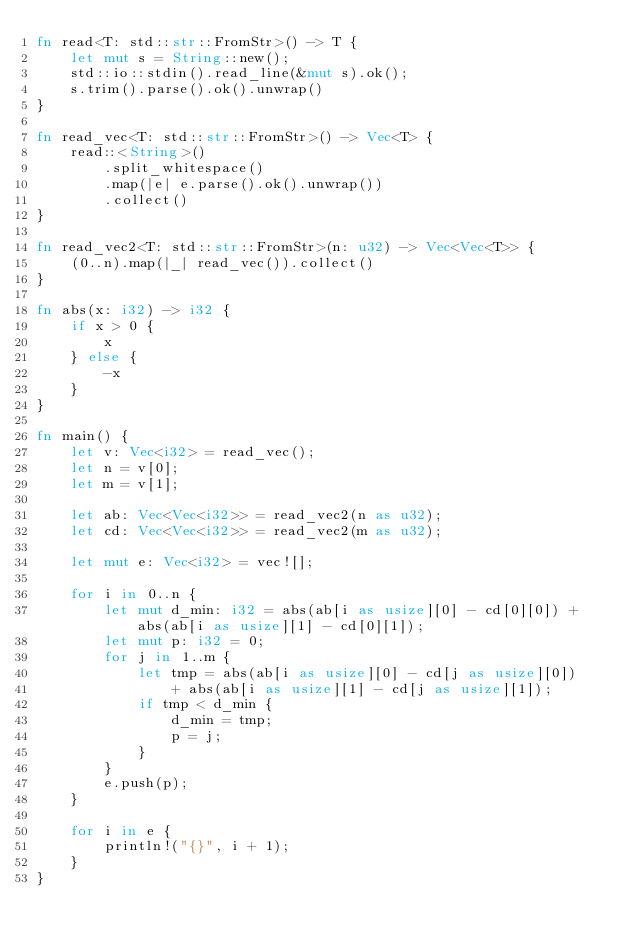<code> <loc_0><loc_0><loc_500><loc_500><_Rust_>fn read<T: std::str::FromStr>() -> T {
    let mut s = String::new();
    std::io::stdin().read_line(&mut s).ok();
    s.trim().parse().ok().unwrap()
}

fn read_vec<T: std::str::FromStr>() -> Vec<T> {
    read::<String>()
        .split_whitespace()
        .map(|e| e.parse().ok().unwrap())
        .collect()
}

fn read_vec2<T: std::str::FromStr>(n: u32) -> Vec<Vec<T>> {
    (0..n).map(|_| read_vec()).collect()
}

fn abs(x: i32) -> i32 {
    if x > 0 {
        x
    } else {
        -x
    }
}

fn main() {
    let v: Vec<i32> = read_vec();
    let n = v[0];
    let m = v[1];

    let ab: Vec<Vec<i32>> = read_vec2(n as u32);
    let cd: Vec<Vec<i32>> = read_vec2(m as u32);

    let mut e: Vec<i32> = vec![];

    for i in 0..n {
        let mut d_min: i32 = abs(ab[i as usize][0] - cd[0][0]) + abs(ab[i as usize][1] - cd[0][1]);
        let mut p: i32 = 0;
        for j in 1..m {
            let tmp = abs(ab[i as usize][0] - cd[j as usize][0])
                + abs(ab[i as usize][1] - cd[j as usize][1]);
            if tmp < d_min {
                d_min = tmp;
                p = j;
            }
        }
        e.push(p);
    }

    for i in e {
        println!("{}", i + 1);
    }
}
</code> 